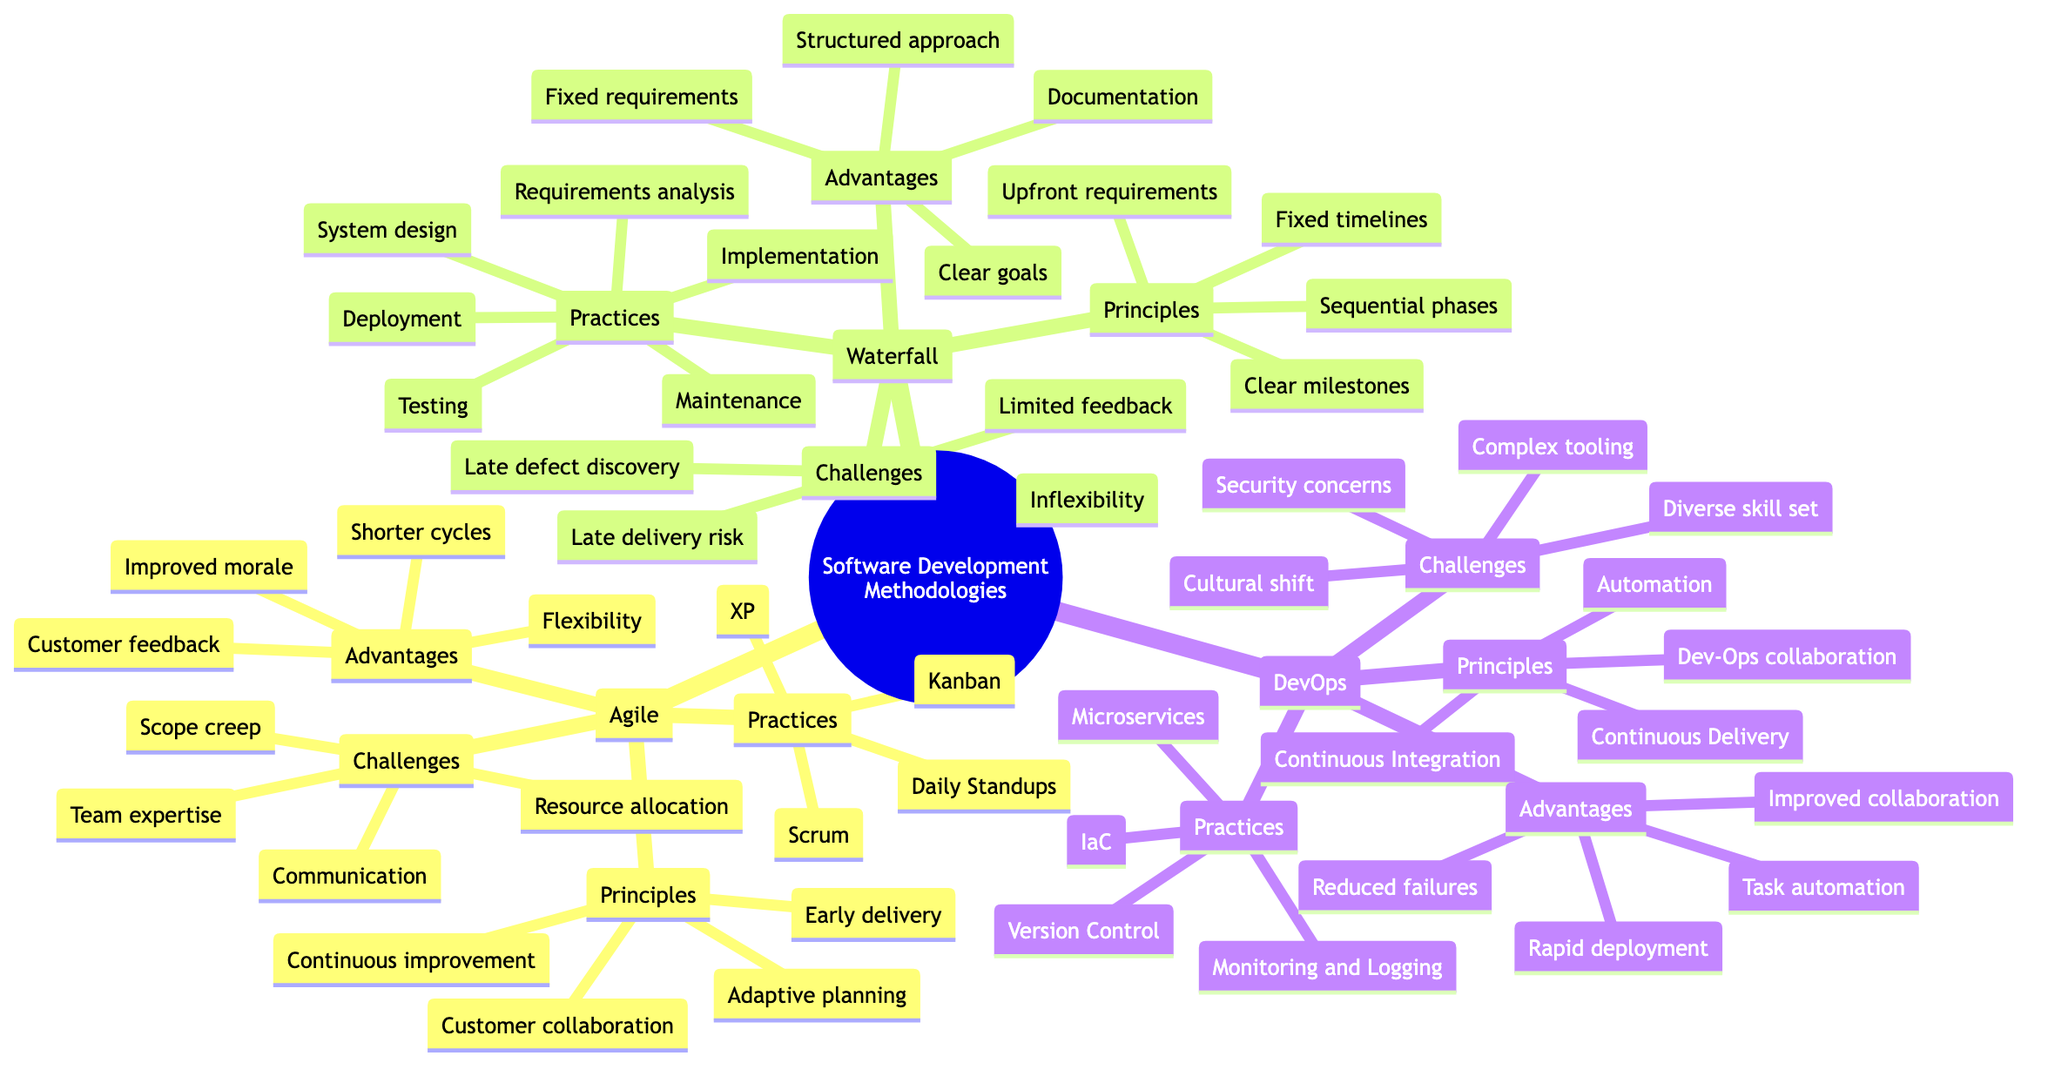What are the principles of Agile? The question asks for the specific principles listed under the Agile section of the mind map. By locating the Agile branch, we can see that it has four listed principles: customer collaboration, adaptive planning, early delivery, and continuous improvement.
Answer: Customer collaboration, adaptive planning, early delivery, continuous improvement How many advantages are listed for Waterfall? To find the answer, we look at the Waterfall section and count the advantages provided. There are four advantages listed for Waterfall: structured approach, documentation, easier to manage projects with fixed requirements, and clear project goals.
Answer: 4 What is one challenge for DevOps? This question seeks any one of the challenges listed under the DevOps section. By reviewing the challenges, we see that cultural shift is one of the listed challenges among others like complex tooling, security concerns, and skill set in both development and operations. Thus, any of these could be correct.
Answer: Cultural shift Which methodology has a principle related to collaboration between Dev and Ops? This question specifically requires identifying the methodology that highlights collaboration between development and operations. By examining the principles of each methodology, we find that "collaboration between Dev and Ops" is a principle listed under DevOps.
Answer: DevOps What is the main advantage of Agile methodology? This question asks for the main advantage, which is subjective; however, if we look closely at the advantages, we might consider flexibility as a key advantage due to its significance in Agile's approach. Nevertheless, other advantages like customer feedback also stand out. In this case, the answer will focus on the listed advantages.
Answer: Flexibility 